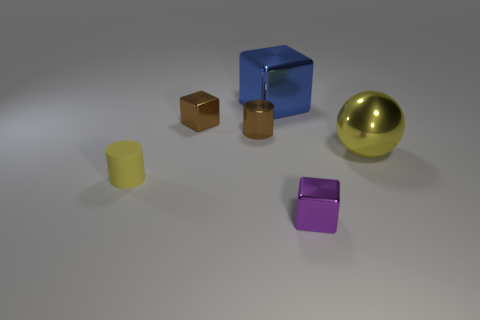Subtract all big blue cubes. How many cubes are left? 2 Subtract 1 blocks. How many blocks are left? 2 Add 2 purple metallic cubes. How many objects exist? 8 Add 4 large yellow metal objects. How many large yellow metal objects exist? 5 Subtract 0 blue balls. How many objects are left? 6 Subtract all balls. How many objects are left? 5 Subtract all red cylinders. Subtract all purple balls. How many cylinders are left? 2 Subtract all spheres. Subtract all brown cylinders. How many objects are left? 4 Add 6 purple things. How many purple things are left? 7 